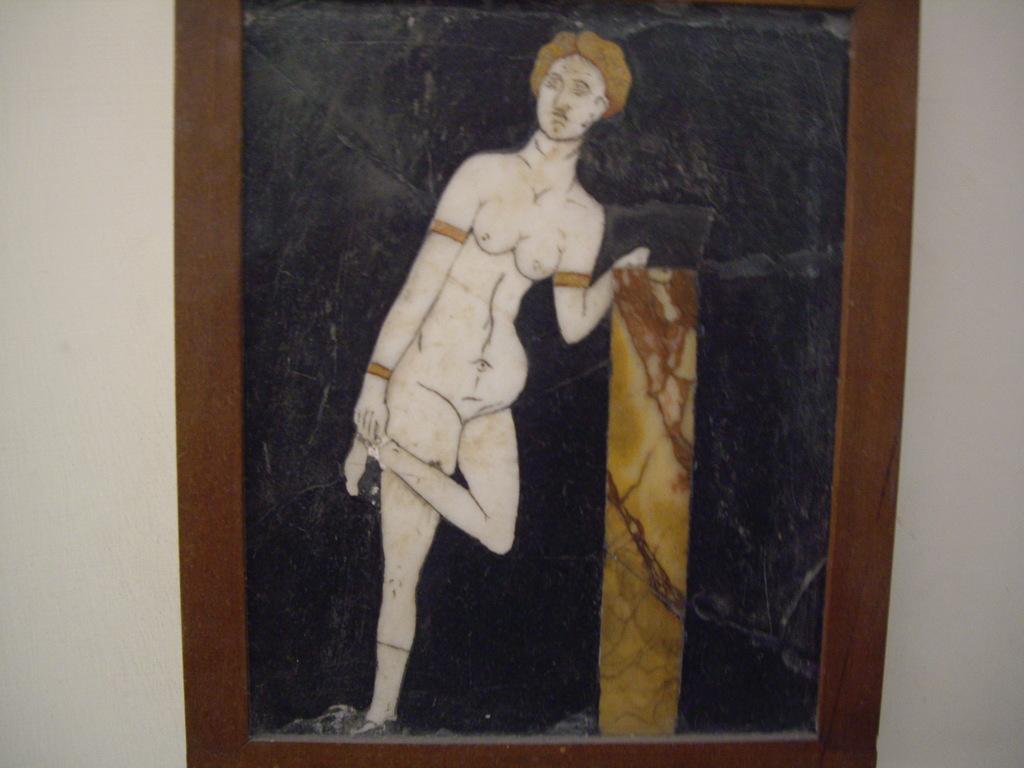How would you summarize this image in a sentence or two? In this picture I can see frame on the wall and looks like a picture of a human. 